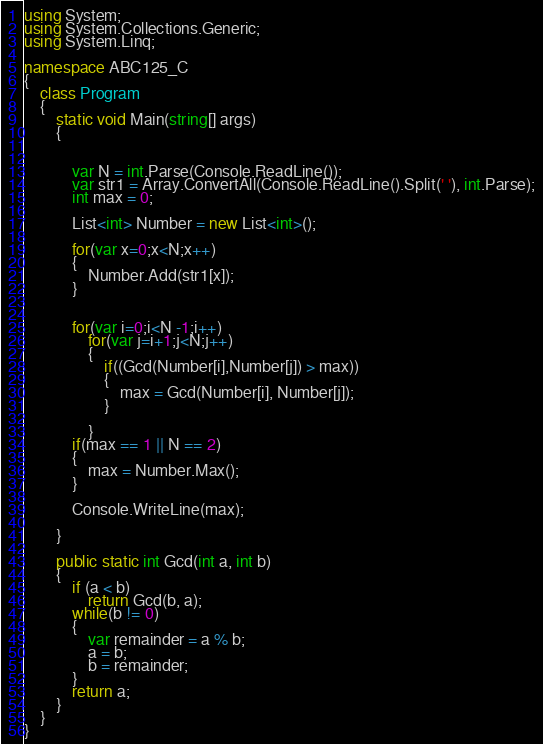<code> <loc_0><loc_0><loc_500><loc_500><_C#_>using System;
using System.Collections.Generic;
using System.Linq;

namespace ABC125_C
{
    class Program
    {
        static void Main(string[] args)
        {
            
            
            var N = int.Parse(Console.ReadLine());
            var str1 = Array.ConvertAll(Console.ReadLine().Split(' '), int.Parse);
            int max = 0;

            List<int> Number = new List<int>();
            
            for(var x=0;x<N;x++)
            {
                Number.Add(str1[x]);
            }


            for(var i=0;i<N -1;i++)
                for(var j=i+1;j<N;j++)
                {
                    if((Gcd(Number[i],Number[j]) > max))
                    {
                        max = Gcd(Number[i], Number[j]);
                    }

                }
            if(max == 1 || N == 2)
            {
                max = Number.Max();
            }

            Console.WriteLine(max);

        }

        public static int Gcd(int a, int b)
        {
            if (a < b)
                return Gcd(b, a);
            while(b != 0)
            {
                var remainder = a % b;
                a = b;
                b = remainder;
            }
            return a;
        }
    }
}
</code> 